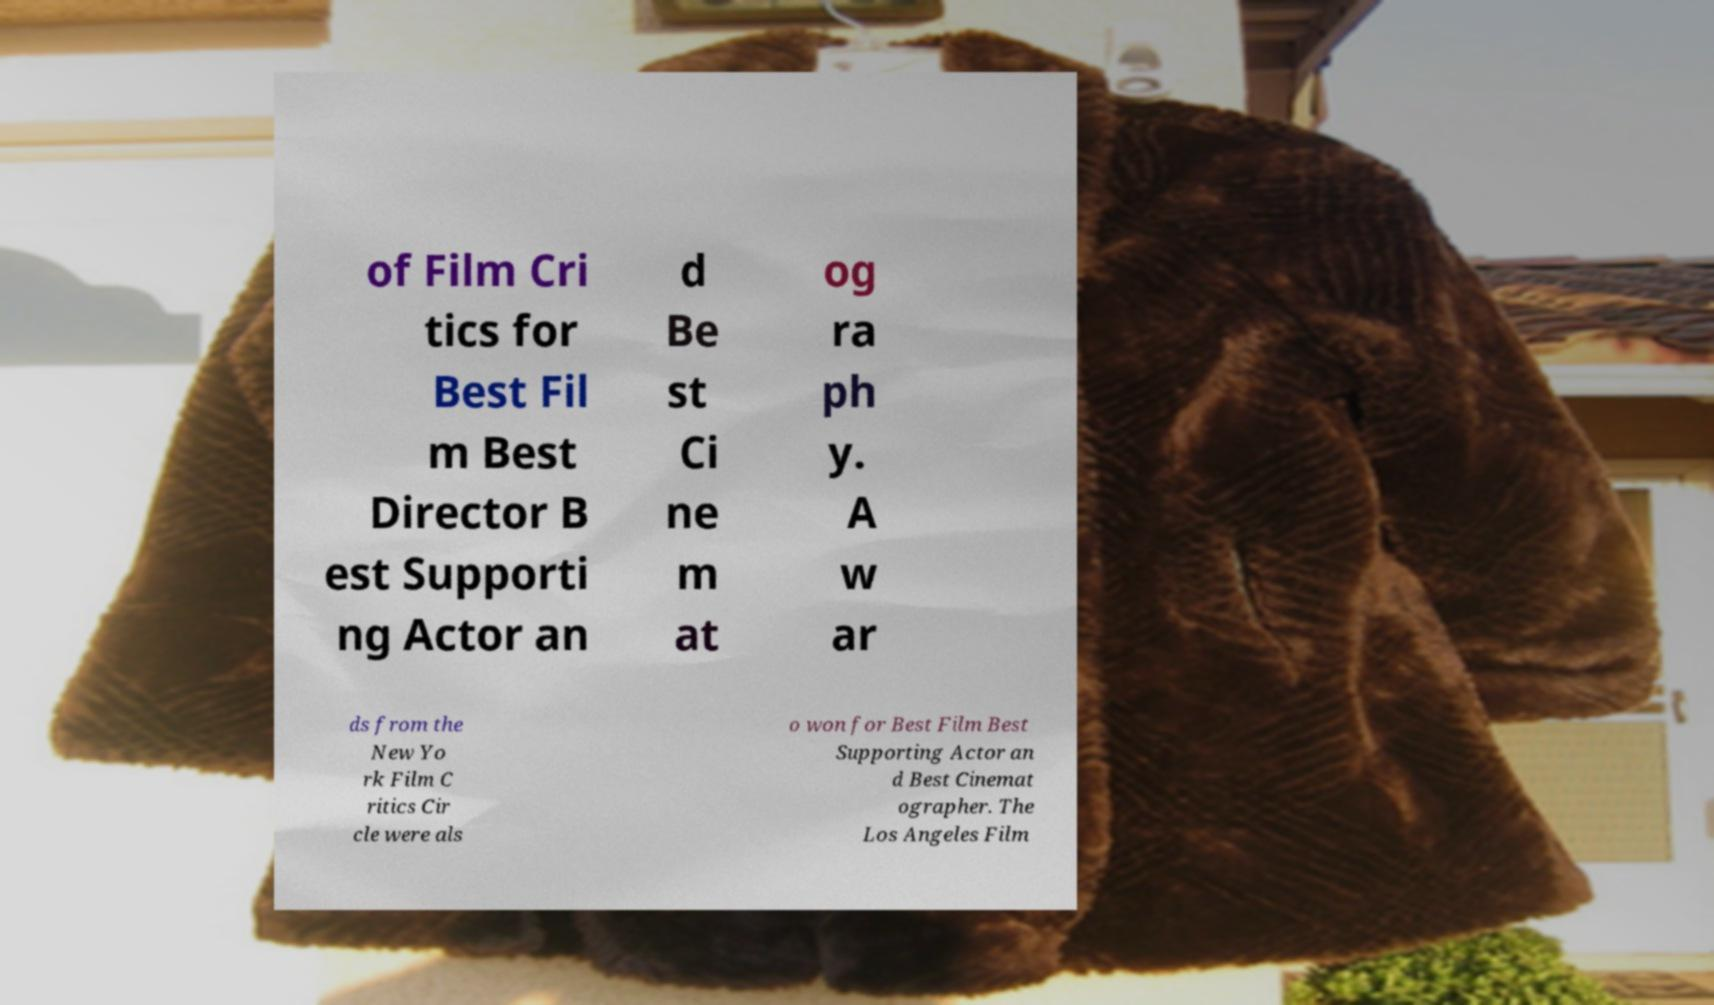Can you read and provide the text displayed in the image?This photo seems to have some interesting text. Can you extract and type it out for me? of Film Cri tics for Best Fil m Best Director B est Supporti ng Actor an d Be st Ci ne m at og ra ph y. A w ar ds from the New Yo rk Film C ritics Cir cle were als o won for Best Film Best Supporting Actor an d Best Cinemat ographer. The Los Angeles Film 